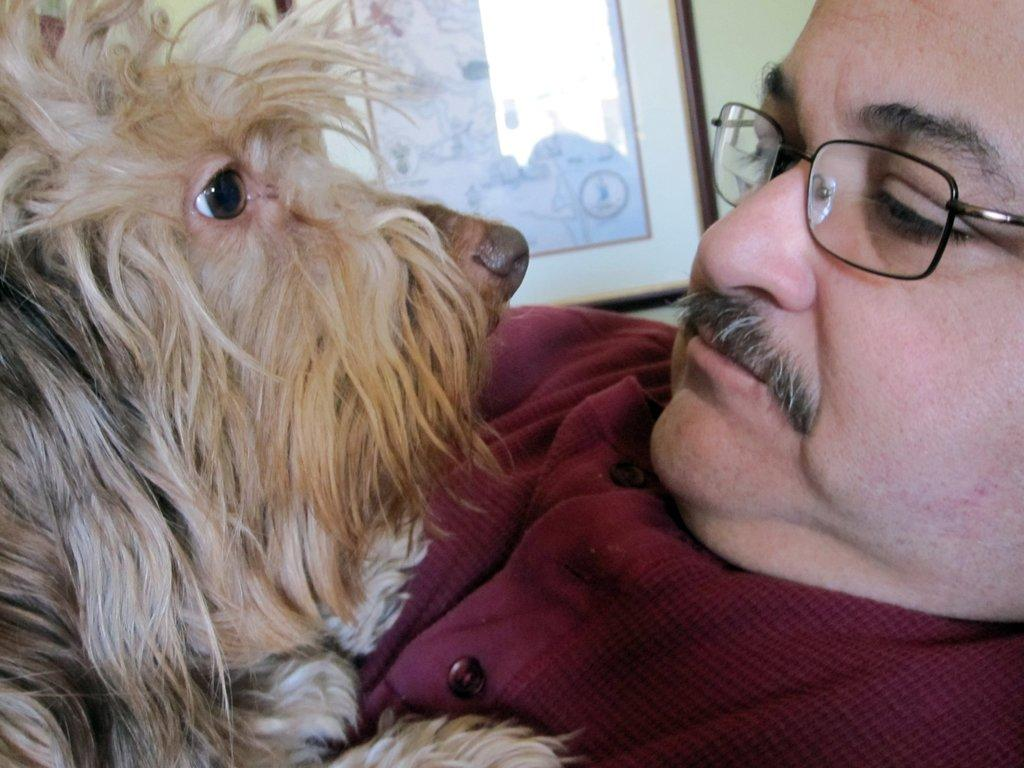What animal is present in the image? There is a dog in the image. What is the dog doing in the image? The dog is on a man. Can you describe the man in the image? The man is wearing glasses. What color is the sky in the image? There is no sky visible in the image, as it is focused on the dog and the man. 